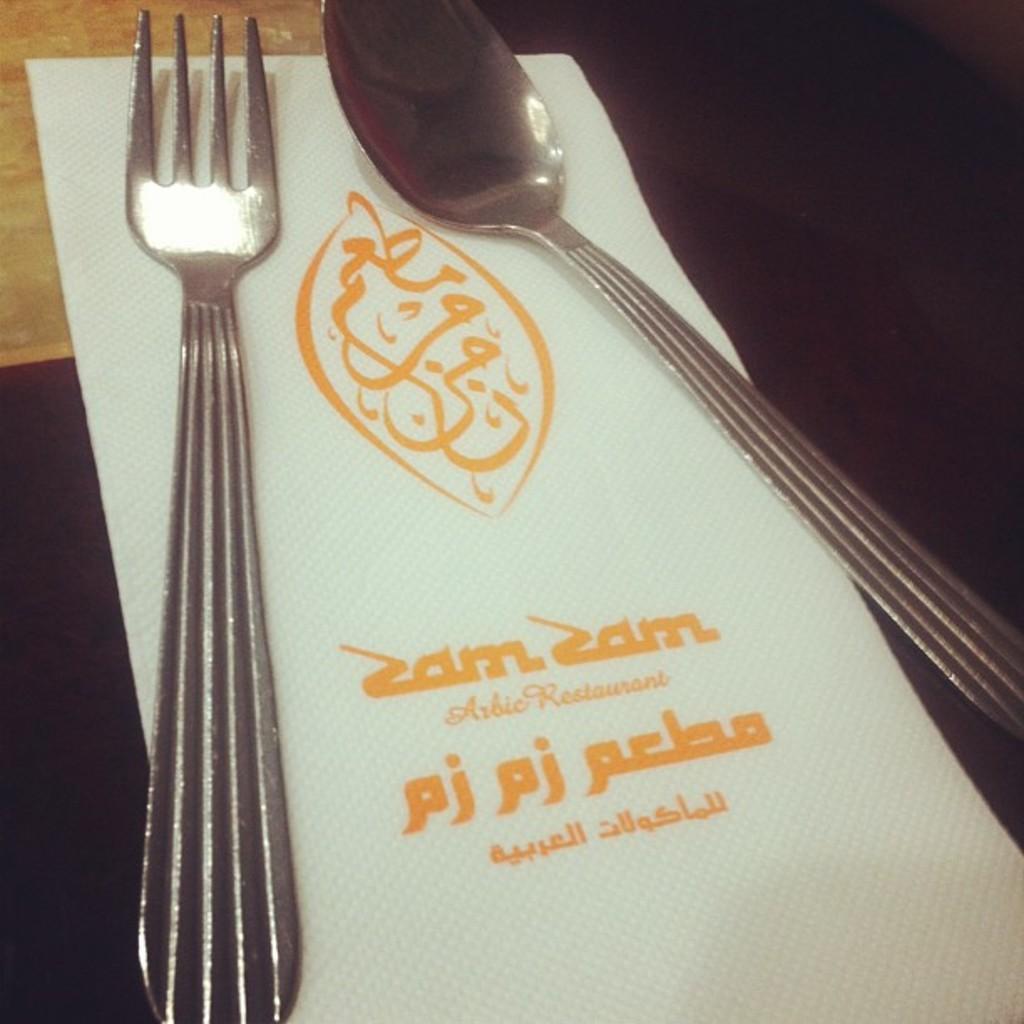How would you summarize this image in a sentence or two? In this image, we can see a spoon and fork on the tissue paper. 